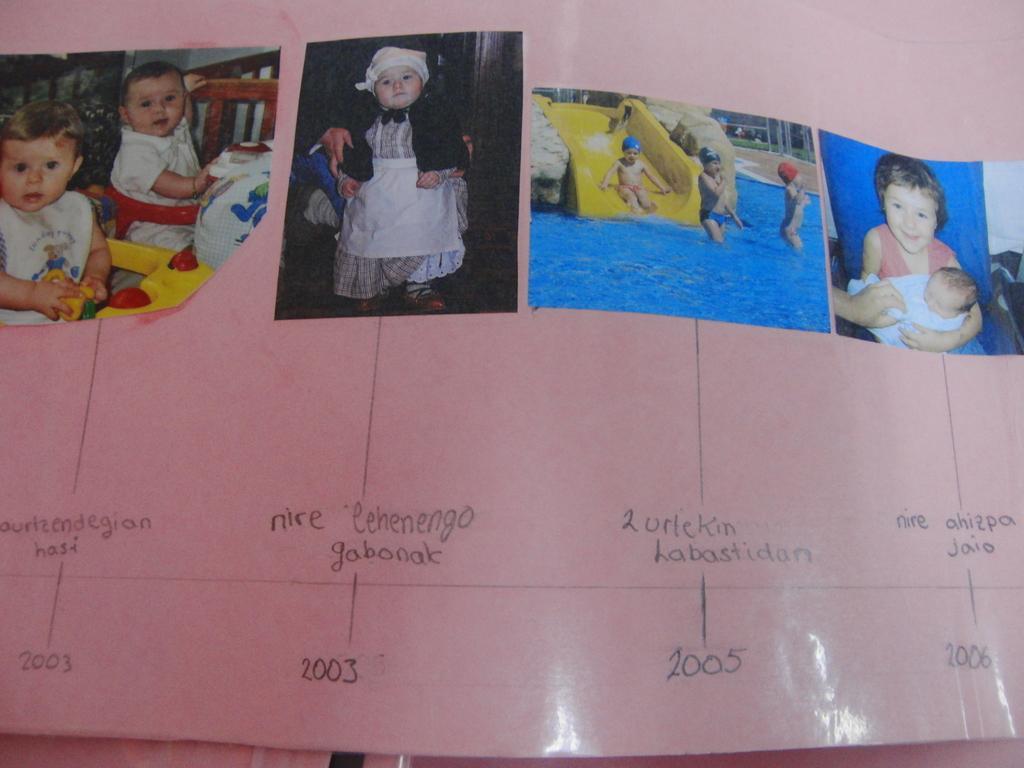In one or two sentences, can you explain what this image depicts? In this image in the front there is a poster and on the poster there are some text and there are images. 